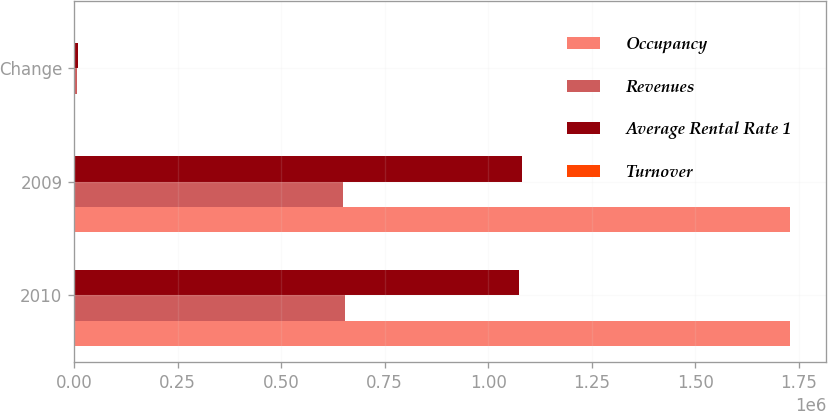<chart> <loc_0><loc_0><loc_500><loc_500><stacked_bar_chart><ecel><fcel>2010<fcel>2009<fcel>Change<nl><fcel>Occupancy<fcel>1.72827e+06<fcel>1.73034e+06<fcel>2067<nl><fcel>Revenues<fcel>654663<fcel>648508<fcel>6155<nl><fcel>Average Rental Rate 1<fcel>1.0736e+06<fcel>1.08183e+06<fcel>8222<nl><fcel>Turnover<fcel>1358<fcel>1375<fcel>17<nl></chart> 